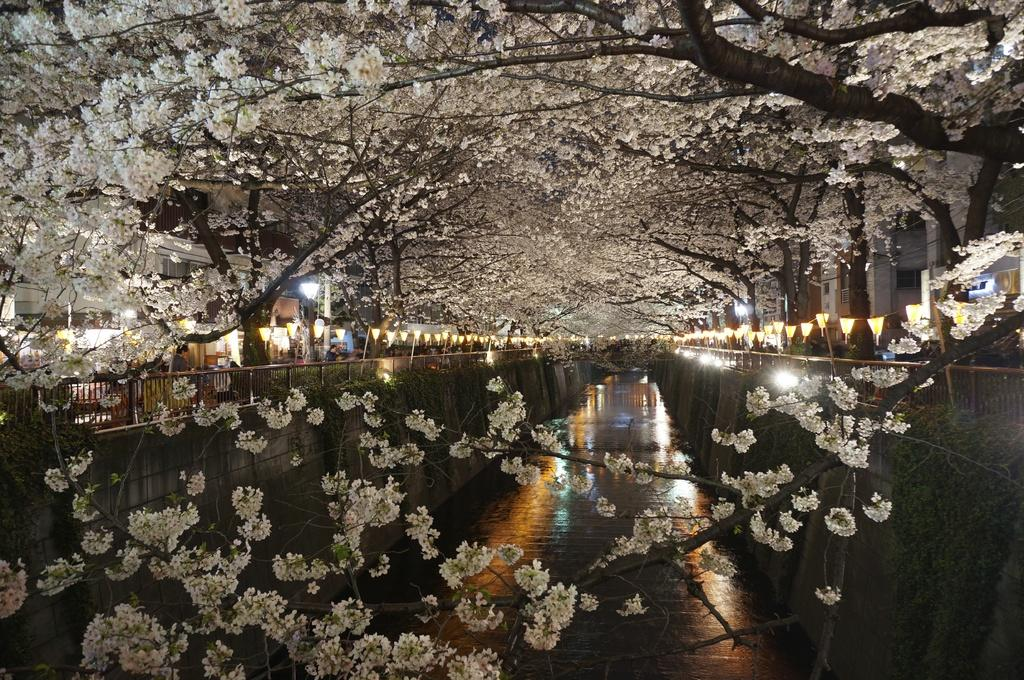What type of vegetation can be seen on the trees in the image? There are flowers on the trees in the image. What is attached to the fencing in the image? There are lights on the fencing in the image. What type of lace can be seen covering the lights in the image? There is no lace present in the image, nor is it covering any lights. What type of string can be seen connecting the flowers on the trees in the image? There is no string connecting the flowers on the trees in the image. 